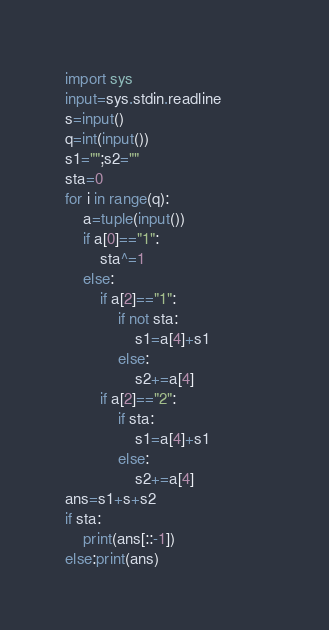Convert code to text. <code><loc_0><loc_0><loc_500><loc_500><_Python_>import sys
input=sys.stdin.readline
s=input()
q=int(input())
s1="";s2=""
sta=0
for i in range(q):
    a=tuple(input())
    if a[0]=="1":
        sta^=1
    else:
        if a[2]=="1":
            if not sta:
                s1=a[4]+s1
            else:
                s2+=a[4]
        if a[2]=="2":
            if sta:
                s1=a[4]+s1
            else:
                s2+=a[4]                
ans=s1+s+s2
if sta:
    print(ans[::-1])
else:print(ans)
</code> 